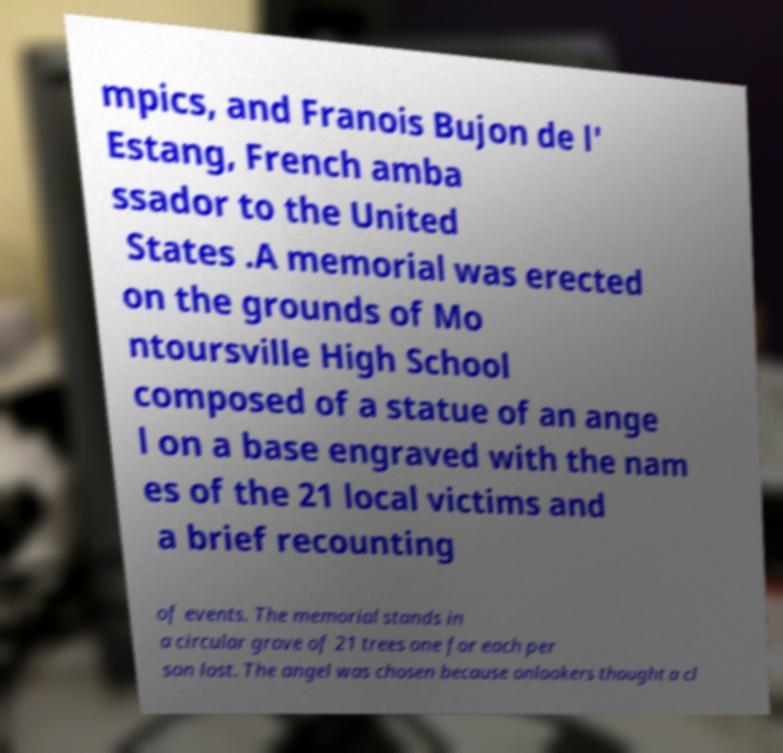There's text embedded in this image that I need extracted. Can you transcribe it verbatim? mpics, and Franois Bujon de l' Estang, French amba ssador to the United States .A memorial was erected on the grounds of Mo ntoursville High School composed of a statue of an ange l on a base engraved with the nam es of the 21 local victims and a brief recounting of events. The memorial stands in a circular grove of 21 trees one for each per son lost. The angel was chosen because onlookers thought a cl 